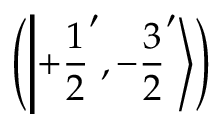<formula> <loc_0><loc_0><loc_500><loc_500>\left ( \left | + { \frac { 1 } { 2 } } ^ { \prime } , - { \frac { 3 } { 2 } } ^ { \prime } \right \rangle \right )</formula> 